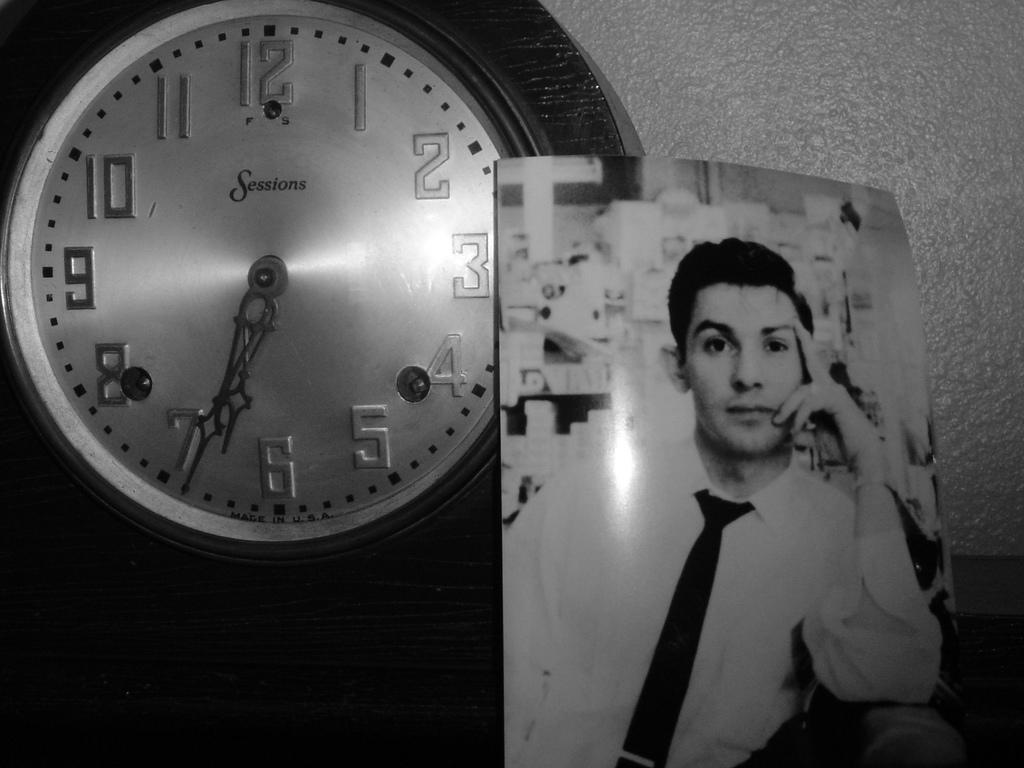<image>
Render a clear and concise summary of the photo. The time is well past 6 o'clock, but not yet 7 o'clock. 